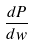<formula> <loc_0><loc_0><loc_500><loc_500>\frac { d P } { d w }</formula> 